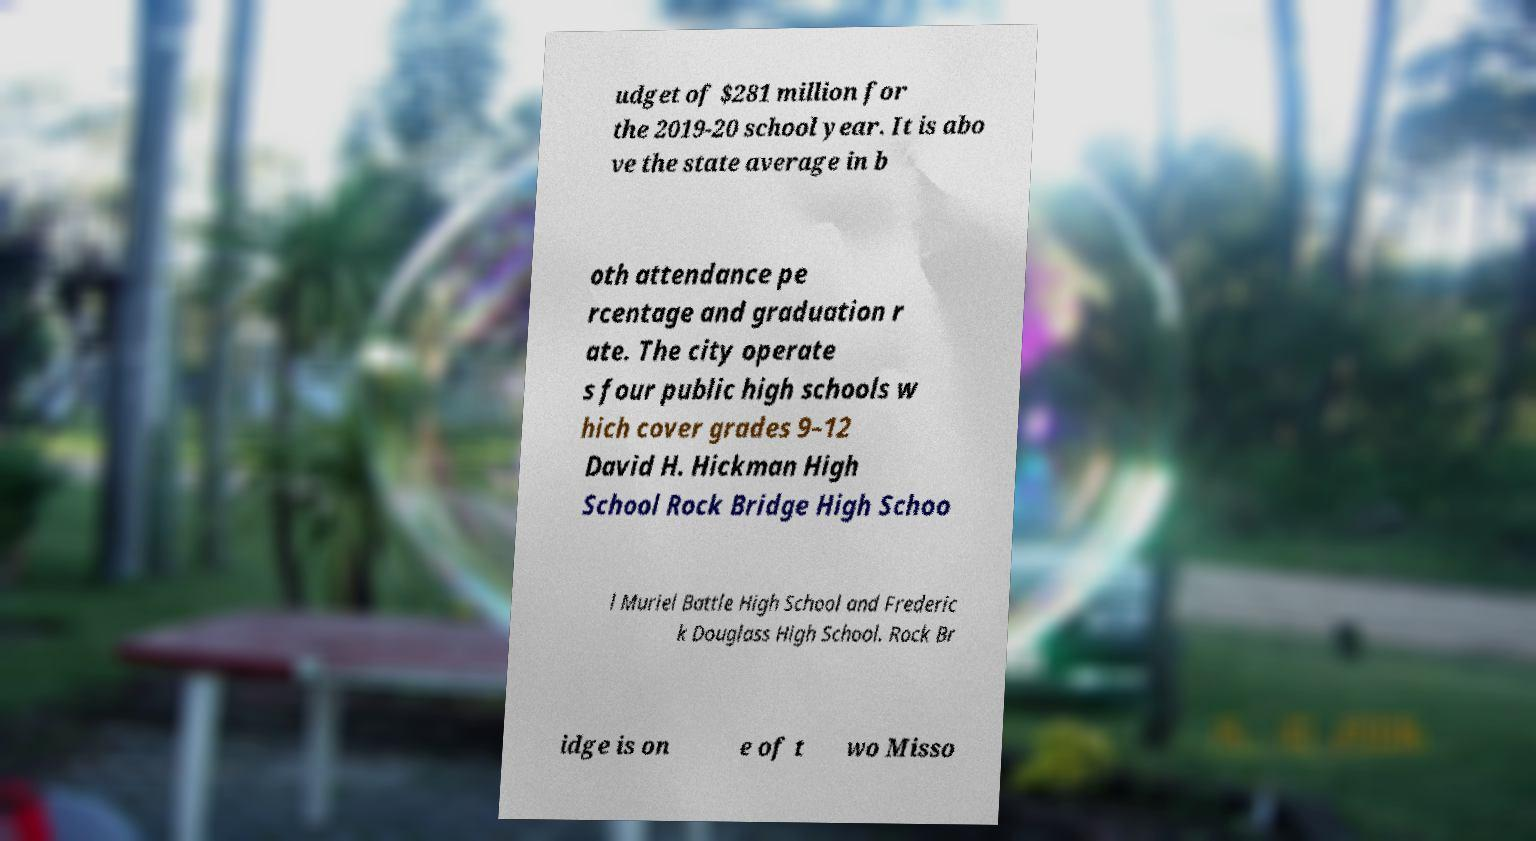Can you accurately transcribe the text from the provided image for me? udget of $281 million for the 2019-20 school year. It is abo ve the state average in b oth attendance pe rcentage and graduation r ate. The city operate s four public high schools w hich cover grades 9–12 David H. Hickman High School Rock Bridge High Schoo l Muriel Battle High School and Frederic k Douglass High School. Rock Br idge is on e of t wo Misso 